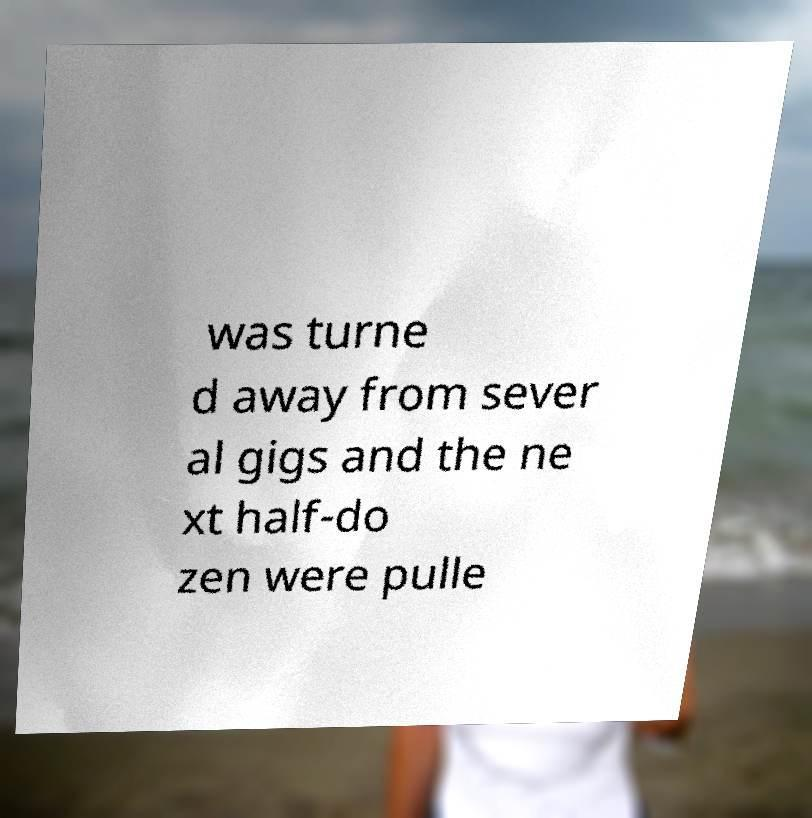Please read and relay the text visible in this image. What does it say? was turne d away from sever al gigs and the ne xt half-do zen were pulle 